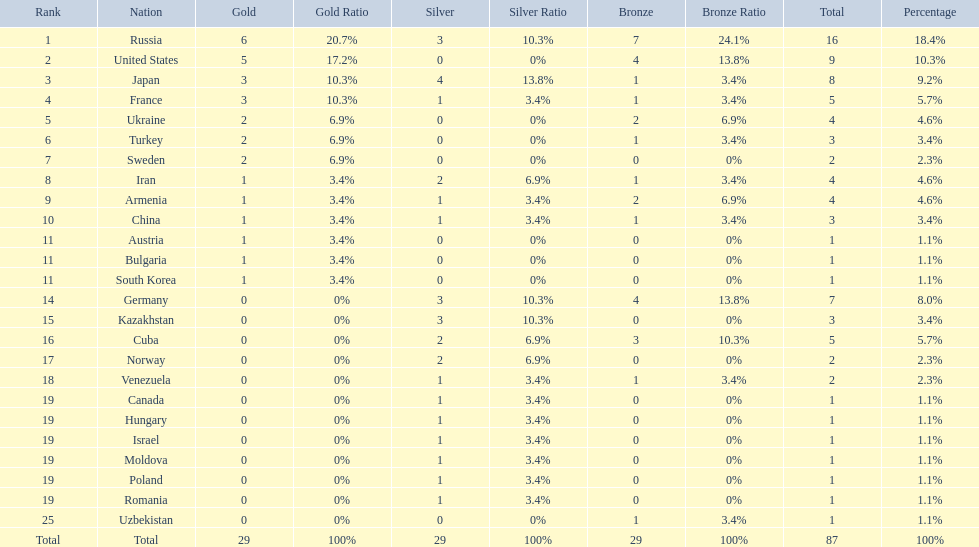Where did iran rank? 8. Where did germany rank? 14. Which of those did make it into the top 10 rank? Germany. 